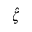Convert formula to latex. <formula><loc_0><loc_0><loc_500><loc_500>\hat { \zeta }</formula> 